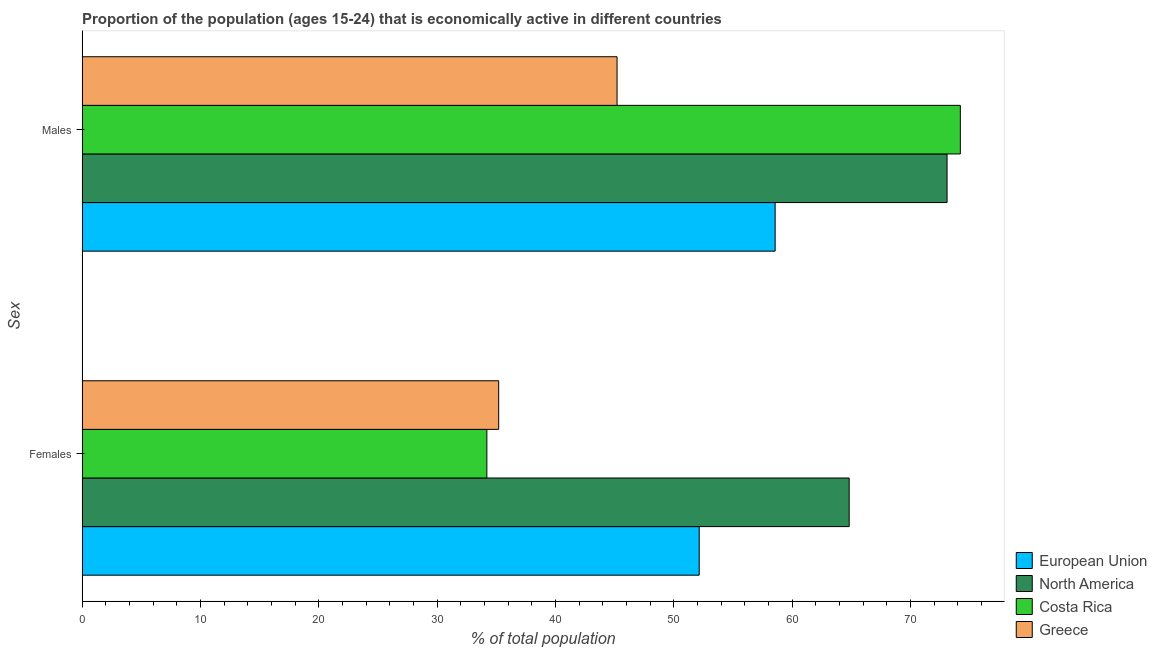How many different coloured bars are there?
Provide a short and direct response. 4. Are the number of bars on each tick of the Y-axis equal?
Give a very brief answer. Yes. How many bars are there on the 1st tick from the top?
Make the answer very short. 4. What is the label of the 1st group of bars from the top?
Provide a short and direct response. Males. What is the percentage of economically active female population in Costa Rica?
Make the answer very short. 34.2. Across all countries, what is the maximum percentage of economically active female population?
Provide a succinct answer. 64.81. Across all countries, what is the minimum percentage of economically active male population?
Ensure brevity in your answer.  45.2. In which country was the percentage of economically active male population maximum?
Your response must be concise. Costa Rica. What is the total percentage of economically active male population in the graph?
Give a very brief answer. 251.03. What is the difference between the percentage of economically active male population in North America and that in European Union?
Give a very brief answer. 14.52. What is the difference between the percentage of economically active female population in Greece and the percentage of economically active male population in North America?
Give a very brief answer. -37.88. What is the average percentage of economically active female population per country?
Keep it short and to the point. 46.59. What is the difference between the percentage of economically active female population and percentage of economically active male population in European Union?
Your response must be concise. -6.42. In how many countries, is the percentage of economically active male population greater than 50 %?
Give a very brief answer. 3. What is the ratio of the percentage of economically active female population in European Union to that in Greece?
Your answer should be very brief. 1.48. Is the percentage of economically active female population in North America less than that in Costa Rica?
Provide a short and direct response. No. In how many countries, is the percentage of economically active male population greater than the average percentage of economically active male population taken over all countries?
Your response must be concise. 2. What does the 3rd bar from the top in Females represents?
Provide a short and direct response. North America. What is the difference between two consecutive major ticks on the X-axis?
Offer a very short reply. 10. Does the graph contain any zero values?
Your answer should be very brief. No. Does the graph contain grids?
Provide a short and direct response. No. Where does the legend appear in the graph?
Ensure brevity in your answer.  Bottom right. How many legend labels are there?
Your answer should be very brief. 4. How are the legend labels stacked?
Provide a short and direct response. Vertical. What is the title of the graph?
Your answer should be compact. Proportion of the population (ages 15-24) that is economically active in different countries. What is the label or title of the X-axis?
Your response must be concise. % of total population. What is the label or title of the Y-axis?
Your answer should be compact. Sex. What is the % of total population in European Union in Females?
Ensure brevity in your answer.  52.14. What is the % of total population of North America in Females?
Your answer should be compact. 64.81. What is the % of total population of Costa Rica in Females?
Offer a terse response. 34.2. What is the % of total population in Greece in Females?
Ensure brevity in your answer.  35.2. What is the % of total population in European Union in Males?
Provide a short and direct response. 58.56. What is the % of total population of North America in Males?
Provide a short and direct response. 73.08. What is the % of total population in Costa Rica in Males?
Your response must be concise. 74.2. What is the % of total population in Greece in Males?
Your answer should be very brief. 45.2. Across all Sex, what is the maximum % of total population in European Union?
Your answer should be compact. 58.56. Across all Sex, what is the maximum % of total population in North America?
Ensure brevity in your answer.  73.08. Across all Sex, what is the maximum % of total population of Costa Rica?
Keep it short and to the point. 74.2. Across all Sex, what is the maximum % of total population of Greece?
Your response must be concise. 45.2. Across all Sex, what is the minimum % of total population in European Union?
Make the answer very short. 52.14. Across all Sex, what is the minimum % of total population of North America?
Keep it short and to the point. 64.81. Across all Sex, what is the minimum % of total population in Costa Rica?
Provide a short and direct response. 34.2. Across all Sex, what is the minimum % of total population in Greece?
Offer a terse response. 35.2. What is the total % of total population of European Union in the graph?
Offer a terse response. 110.69. What is the total % of total population of North America in the graph?
Give a very brief answer. 137.89. What is the total % of total population in Costa Rica in the graph?
Keep it short and to the point. 108.4. What is the total % of total population in Greece in the graph?
Give a very brief answer. 80.4. What is the difference between the % of total population in European Union in Females and that in Males?
Ensure brevity in your answer.  -6.42. What is the difference between the % of total population of North America in Females and that in Males?
Provide a short and direct response. -8.27. What is the difference between the % of total population of European Union in Females and the % of total population of North America in Males?
Offer a very short reply. -20.94. What is the difference between the % of total population of European Union in Females and the % of total population of Costa Rica in Males?
Your answer should be compact. -22.06. What is the difference between the % of total population of European Union in Females and the % of total population of Greece in Males?
Provide a succinct answer. 6.94. What is the difference between the % of total population in North America in Females and the % of total population in Costa Rica in Males?
Offer a very short reply. -9.39. What is the difference between the % of total population of North America in Females and the % of total population of Greece in Males?
Ensure brevity in your answer.  19.61. What is the difference between the % of total population in Costa Rica in Females and the % of total population in Greece in Males?
Offer a very short reply. -11. What is the average % of total population in European Union per Sex?
Your response must be concise. 55.35. What is the average % of total population in North America per Sex?
Offer a terse response. 68.94. What is the average % of total population of Costa Rica per Sex?
Your answer should be compact. 54.2. What is the average % of total population of Greece per Sex?
Ensure brevity in your answer.  40.2. What is the difference between the % of total population in European Union and % of total population in North America in Females?
Keep it short and to the point. -12.67. What is the difference between the % of total population of European Union and % of total population of Costa Rica in Females?
Keep it short and to the point. 17.94. What is the difference between the % of total population in European Union and % of total population in Greece in Females?
Offer a very short reply. 16.94. What is the difference between the % of total population in North America and % of total population in Costa Rica in Females?
Make the answer very short. 30.61. What is the difference between the % of total population of North America and % of total population of Greece in Females?
Give a very brief answer. 29.61. What is the difference between the % of total population of Costa Rica and % of total population of Greece in Females?
Give a very brief answer. -1. What is the difference between the % of total population in European Union and % of total population in North America in Males?
Ensure brevity in your answer.  -14.52. What is the difference between the % of total population of European Union and % of total population of Costa Rica in Males?
Provide a succinct answer. -15.64. What is the difference between the % of total population of European Union and % of total population of Greece in Males?
Offer a very short reply. 13.36. What is the difference between the % of total population of North America and % of total population of Costa Rica in Males?
Provide a short and direct response. -1.12. What is the difference between the % of total population of North America and % of total population of Greece in Males?
Give a very brief answer. 27.88. What is the ratio of the % of total population in European Union in Females to that in Males?
Your response must be concise. 0.89. What is the ratio of the % of total population of North America in Females to that in Males?
Your answer should be very brief. 0.89. What is the ratio of the % of total population in Costa Rica in Females to that in Males?
Offer a very short reply. 0.46. What is the ratio of the % of total population in Greece in Females to that in Males?
Give a very brief answer. 0.78. What is the difference between the highest and the second highest % of total population of European Union?
Keep it short and to the point. 6.42. What is the difference between the highest and the second highest % of total population in North America?
Offer a terse response. 8.27. What is the difference between the highest and the second highest % of total population in Costa Rica?
Provide a short and direct response. 40. What is the difference between the highest and the second highest % of total population of Greece?
Your answer should be compact. 10. What is the difference between the highest and the lowest % of total population in European Union?
Your answer should be very brief. 6.42. What is the difference between the highest and the lowest % of total population in North America?
Your answer should be very brief. 8.27. What is the difference between the highest and the lowest % of total population of Costa Rica?
Offer a terse response. 40. What is the difference between the highest and the lowest % of total population of Greece?
Your response must be concise. 10. 